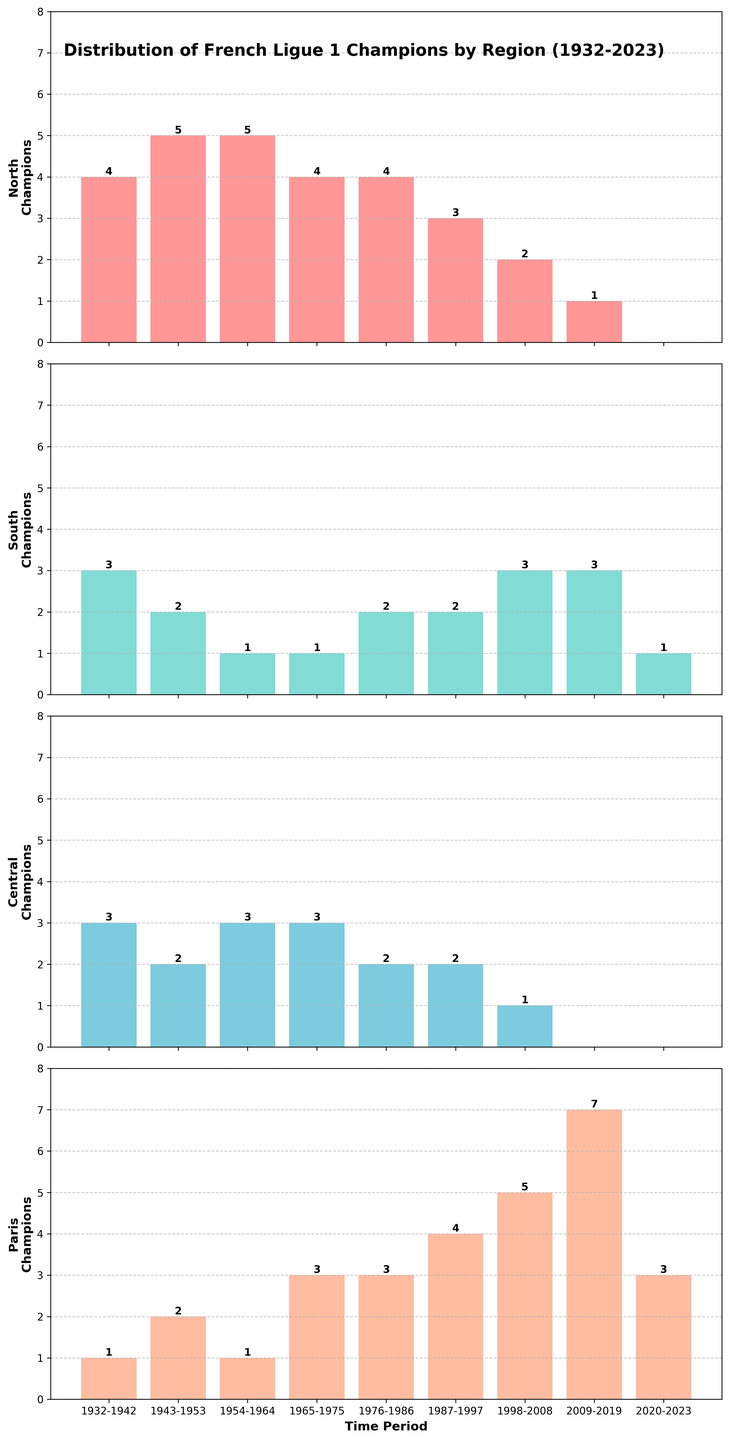What's the total number of Ligue 1 championships won by teams from the North and Paris regions during the period 1987-1997? To find the total, sum the number of championships in the North and Paris regions for 1987-1997. North: 3, Paris: 4. So, 3 + 4 = 7.
Answer: 7 Which region had the most sustained increase in championship wins from 2009-2019 to 2020-2023? Compare the number of championships in all regions between these two periods. From the plot, Paris increased from 7 to 3 (a decrease); the South went from 3 to 1 (a decrease); Central stayed at 0; North went from 1 to 0 (a decrease). Therefore, none of the regions had an increase, and all had a decrease or stayed the same.
Answer: None In which period did the Central region win the most Ligue 1 championships? Look for the period in which the Central region has the highest bar. The tallest bar for Central is during the period 1932-1942 and 1965-1975, each with a height of 3.
Answer: 1932-1942 & 1965-1975 What is the difference in the number of championships between the North and South regions in the period 1943-1953? For 1943-1953, the North won 5 championships, and the South won 2. The difference is 5 - 2 = 3.
Answer: 3 Which region had the highest number of championship wins since 2009? Compare the heights of bars for each region from 2009 onwards. The bar for Paris is the highest with 7 championships from 2009-2019 and 3 from 2020-2023.
Answer: Paris What is the average number of championship wins for the North region from 1932-2023? Sum the numbers for the North region: 4 + 5 + 5 + 4 + 4 + 3 + 2 + 1 + 0 = 28. There are 9 periods, so the average is 28 / 9 ≈ 3.11.
Answer: 3.11 Which region saw the largest decrease in championship wins between consecutive periods? Look for the largest height change between consecutive periods for each region. The largest decrease is seen in the Paris region, from 7 (2009-2019) to 3 (2020-2023), a drop of 4 championships.
Answer: Paris During which decade did the South region see its highest peak of championship wins? Look for the tallest bar for the South region. The tallest bar is in 1932-1942 and 1998-2008, each with a height of 3.
Answer: 1932-1942 & 1998-2008 